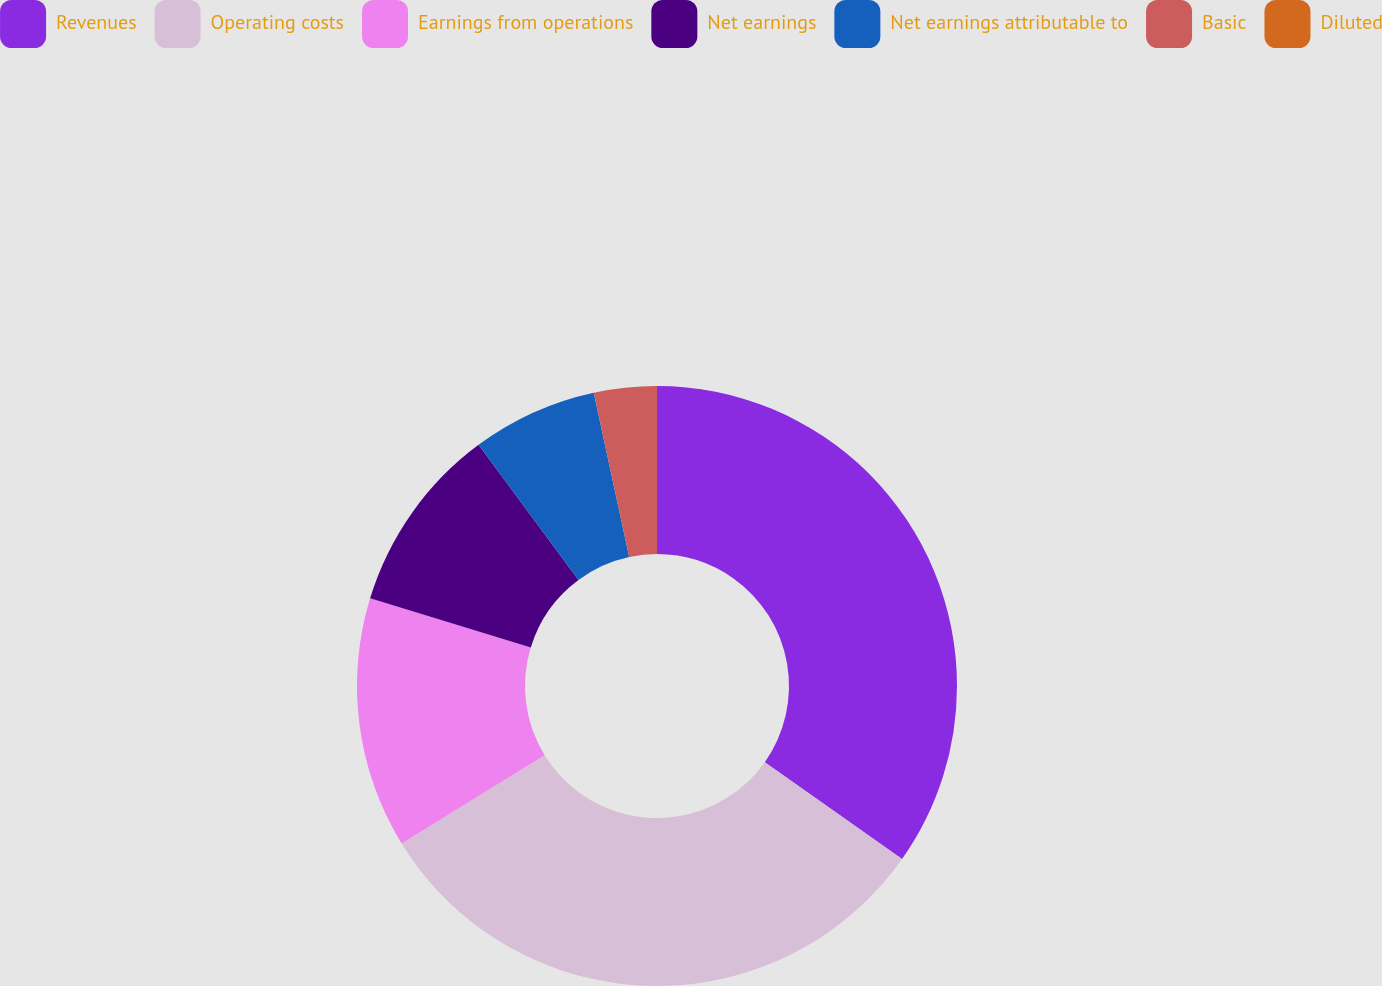<chart> <loc_0><loc_0><loc_500><loc_500><pie_chart><fcel>Revenues<fcel>Operating costs<fcel>Earnings from operations<fcel>Net earnings<fcel>Net earnings attributable to<fcel>Basic<fcel>Diluted<nl><fcel>34.79%<fcel>31.42%<fcel>13.51%<fcel>10.14%<fcel>6.76%<fcel>3.38%<fcel>0.0%<nl></chart> 